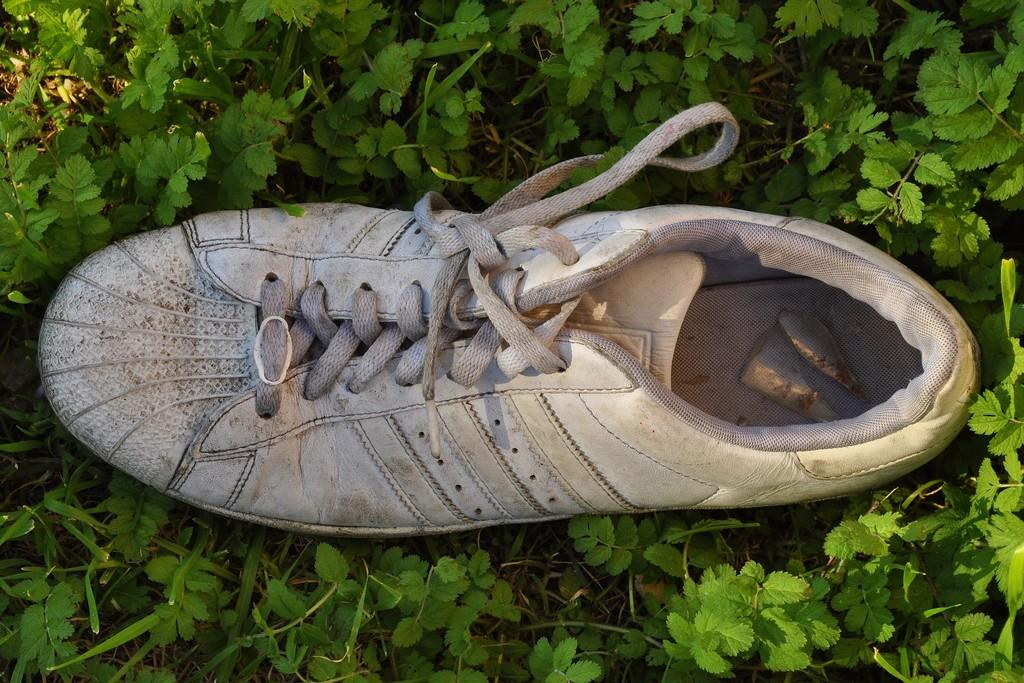What color is the shoe in the image? The shoe in the image is white. What can be seen around the shoe in the image? There are green color plants around the shoe. What type of string is used to hold the shoe and plants together in the image? There is no string present in the image; the shoe and plants are not connected. 